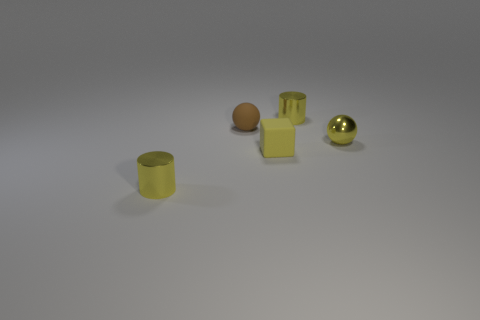There is a cube that is the same color as the metal ball; what size is it?
Offer a very short reply. Small. What shape is the small matte thing that is the same color as the metal ball?
Make the answer very short. Cube. There is a tiny object that is the same material as the tiny brown ball; what is its shape?
Give a very brief answer. Cube. What size is the ball that is behind the ball in front of the brown rubber sphere?
Provide a succinct answer. Small. How many objects are either tiny things behind the matte cube or small balls that are in front of the brown rubber sphere?
Provide a short and direct response. 3. Are there fewer large red matte cubes than tiny yellow matte things?
Make the answer very short. Yes. How many things are big purple things or small spheres?
Provide a short and direct response. 2. Do the small yellow rubber thing and the small brown object have the same shape?
Offer a terse response. No. Are there any other things that have the same material as the brown sphere?
Offer a very short reply. Yes. There is a yellow metallic cylinder that is behind the tiny brown ball; is it the same size as the yellow cylinder that is in front of the small brown rubber ball?
Offer a very short reply. Yes. 